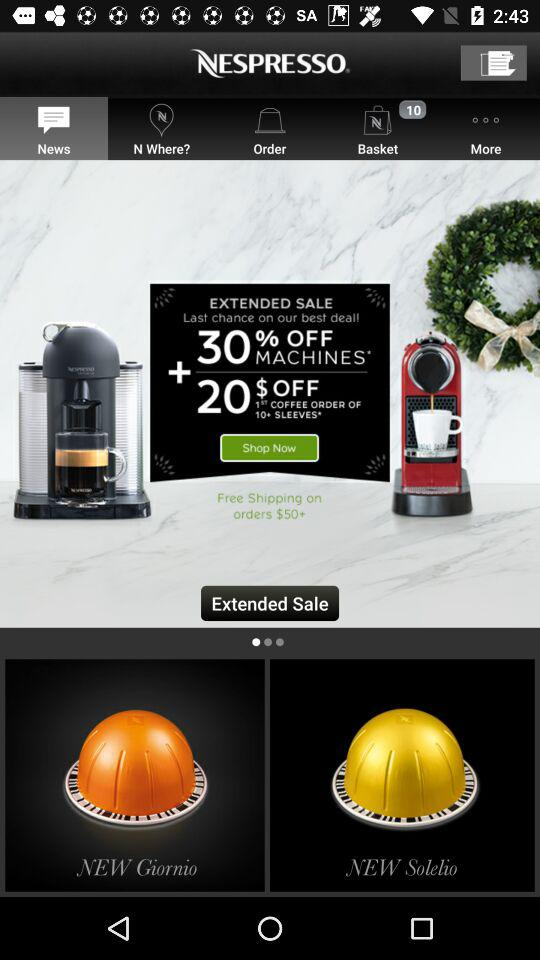What is the application name? The application name is "NESPRESSO". 